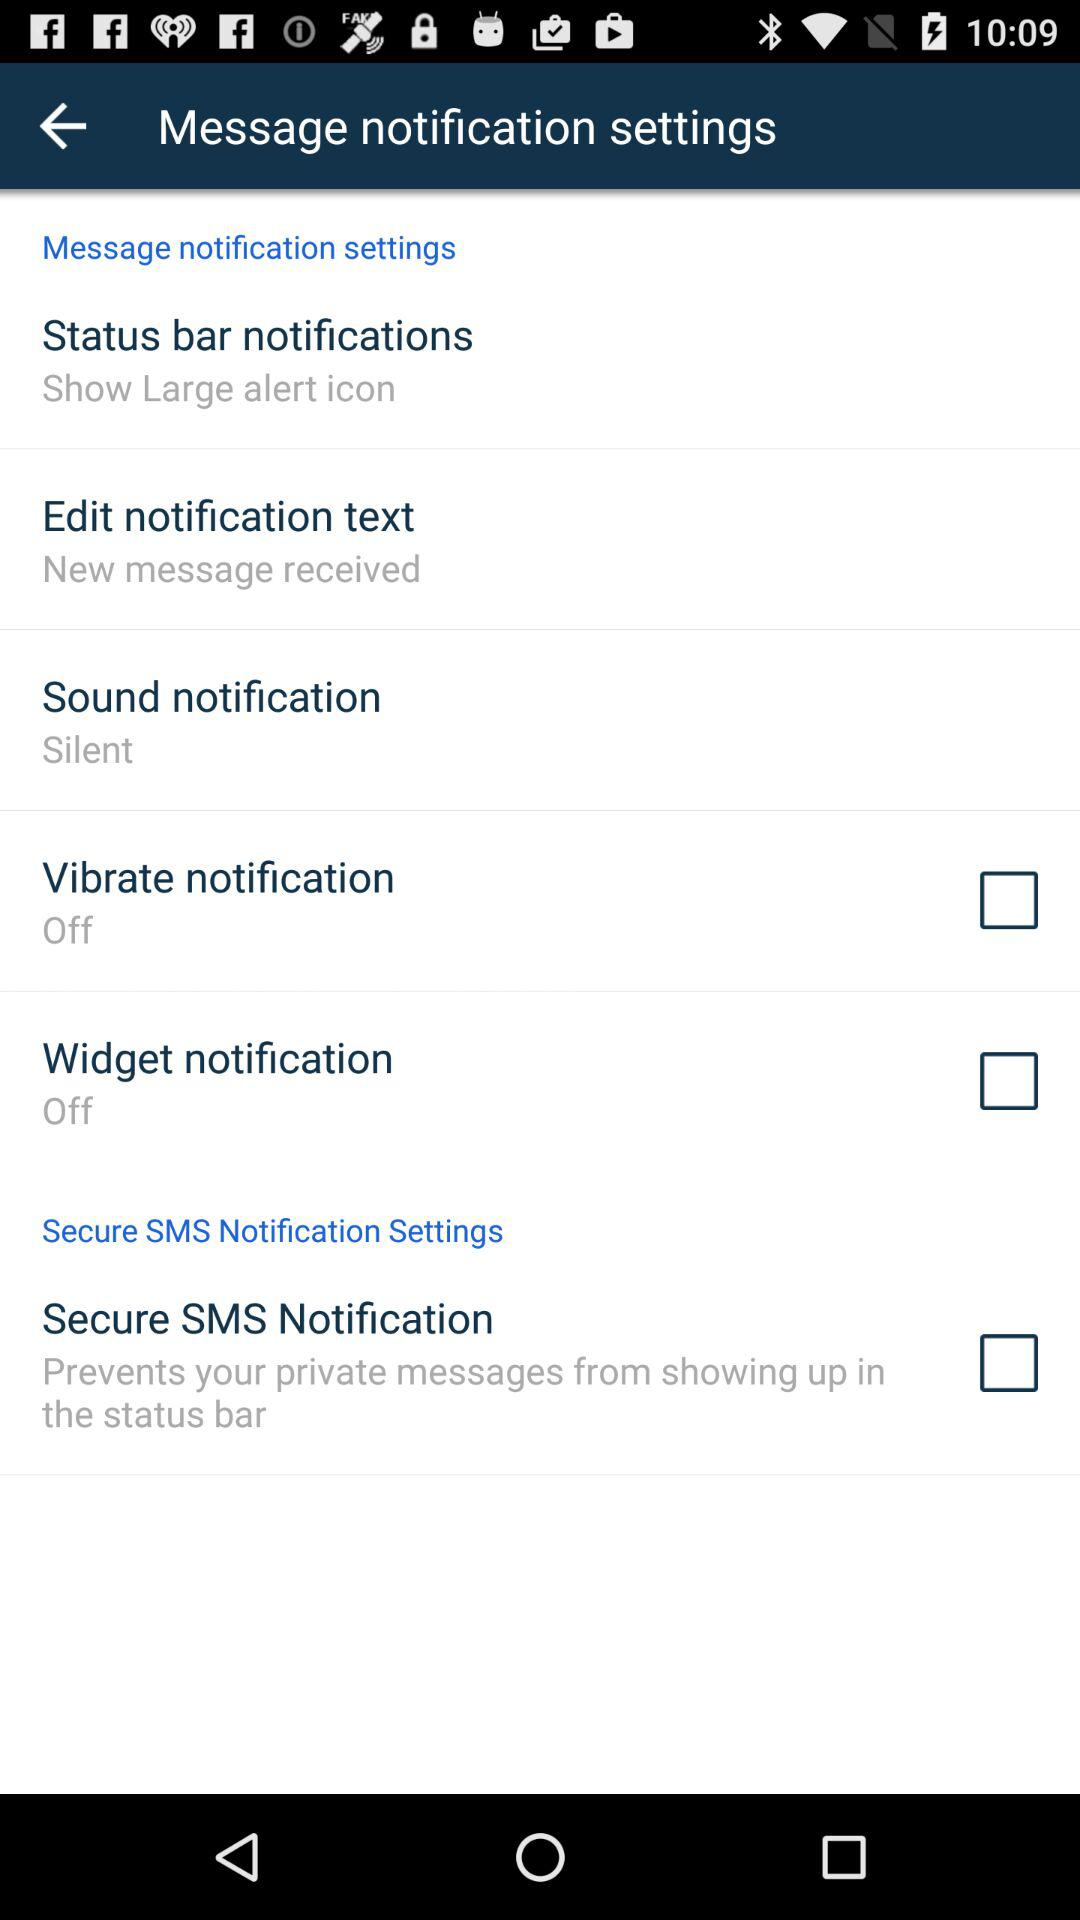What is the status of "Vibrate notification"? The status is "off". 